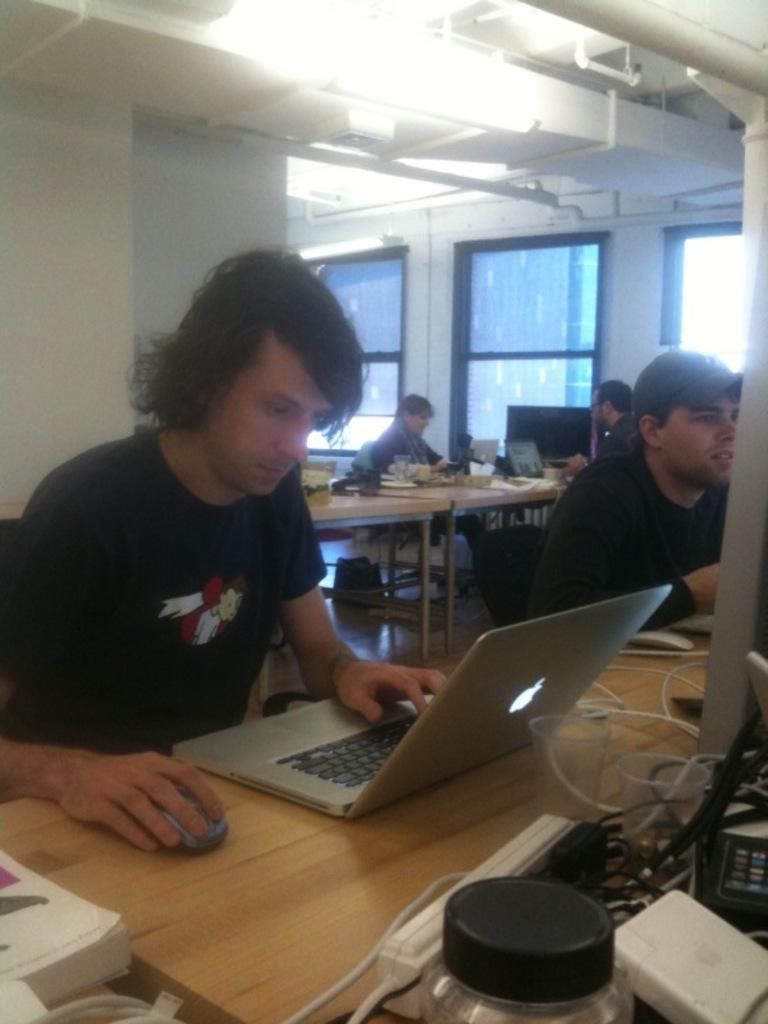How many people are in the image are sitting on chairs? There is a group of people in the image, and they are all sitting on chairs. What objects can be seen on the table in the image? There is a laptop and a battery on the table in the image. What is visible in the background of the image? There is a window and a pillar in the background of the image. What type of grass is growing on the laptop in the image? There is no grass present in the image; the laptop is on the table without any grass. 